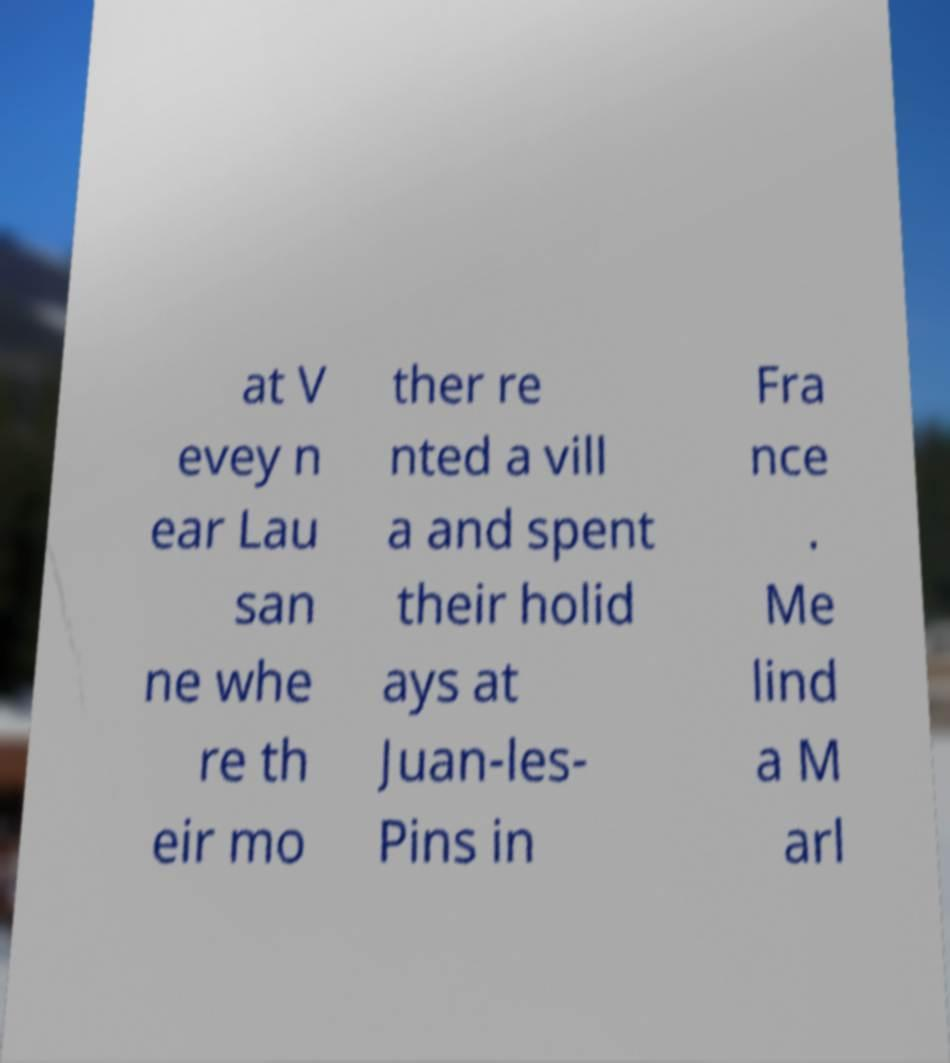There's text embedded in this image that I need extracted. Can you transcribe it verbatim? at V evey n ear Lau san ne whe re th eir mo ther re nted a vill a and spent their holid ays at Juan-les- Pins in Fra nce . Me lind a M arl 